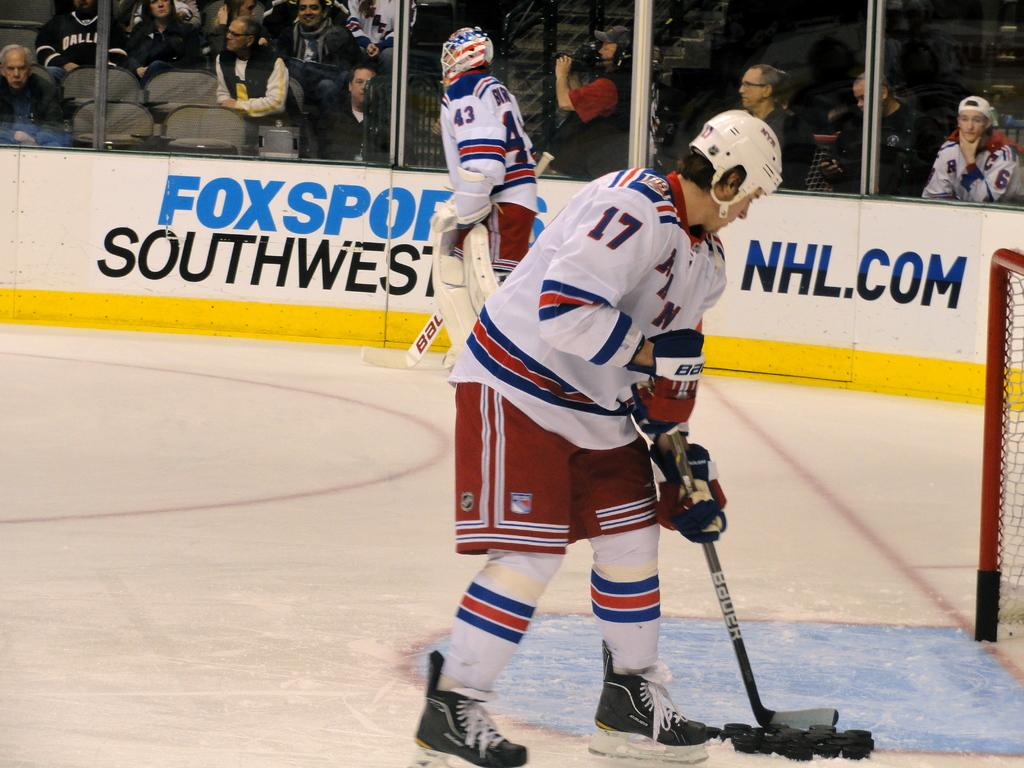<image>
Write a terse but informative summary of the picture. A hockey game is going on at the Fox Sports Southwest stadium. 